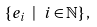<formula> <loc_0><loc_0><loc_500><loc_500>\{ e _ { i } \ | \ i \in \mathbb { N } \} \, ,</formula> 